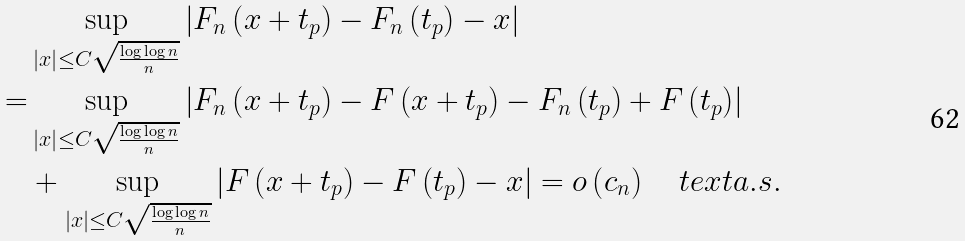Convert formula to latex. <formula><loc_0><loc_0><loc_500><loc_500>& \sup _ { \left | x \right | \leq C \sqrt { \frac { \log \log n } { n } } } \left | F _ { n } \left ( x + t _ { p } \right ) - F _ { n } \left ( t _ { p } \right ) - x \right | \\ = & \sup _ { \left | x \right | \leq C \sqrt { \frac { \log \log n } { n } } } \left | F _ { n } \left ( x + t _ { p } \right ) - F \left ( x + t _ { p } \right ) - F _ { n } \left ( t _ { p } \right ) + F \left ( t _ { p } \right ) \right | \\ & + \sup _ { \left | x \right | \leq C \sqrt { \frac { \log \log n } { n } } } \left | F \left ( x + t _ { p } \right ) - F \left ( t _ { p } \right ) - x \right | = o \left ( c _ { n } \right ) \quad t e x t { a . s . }</formula> 